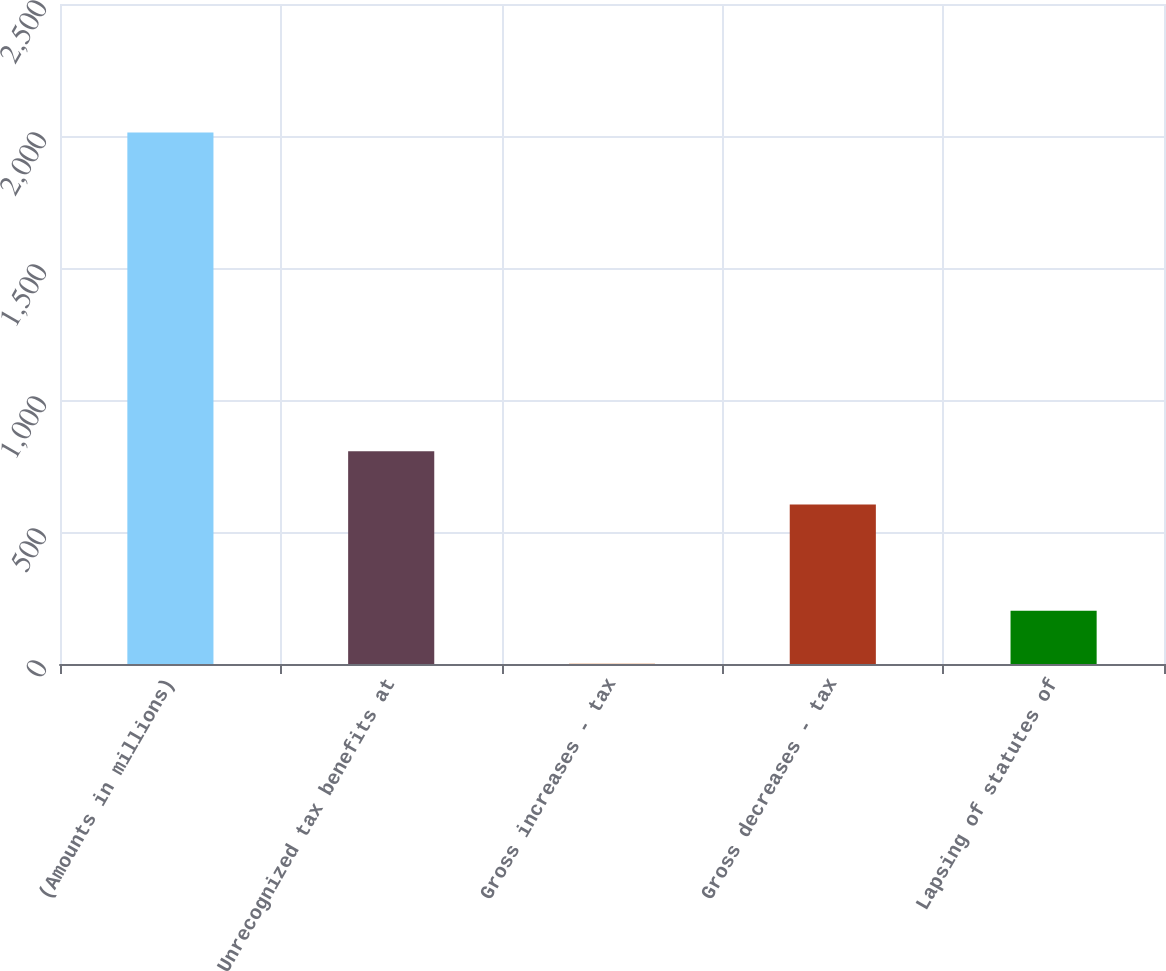Convert chart. <chart><loc_0><loc_0><loc_500><loc_500><bar_chart><fcel>(Amounts in millions)<fcel>Unrecognized tax benefits at<fcel>Gross increases - tax<fcel>Gross decreases - tax<fcel>Lapsing of statutes of<nl><fcel>2013<fcel>805.5<fcel>0.5<fcel>604.25<fcel>201.75<nl></chart> 